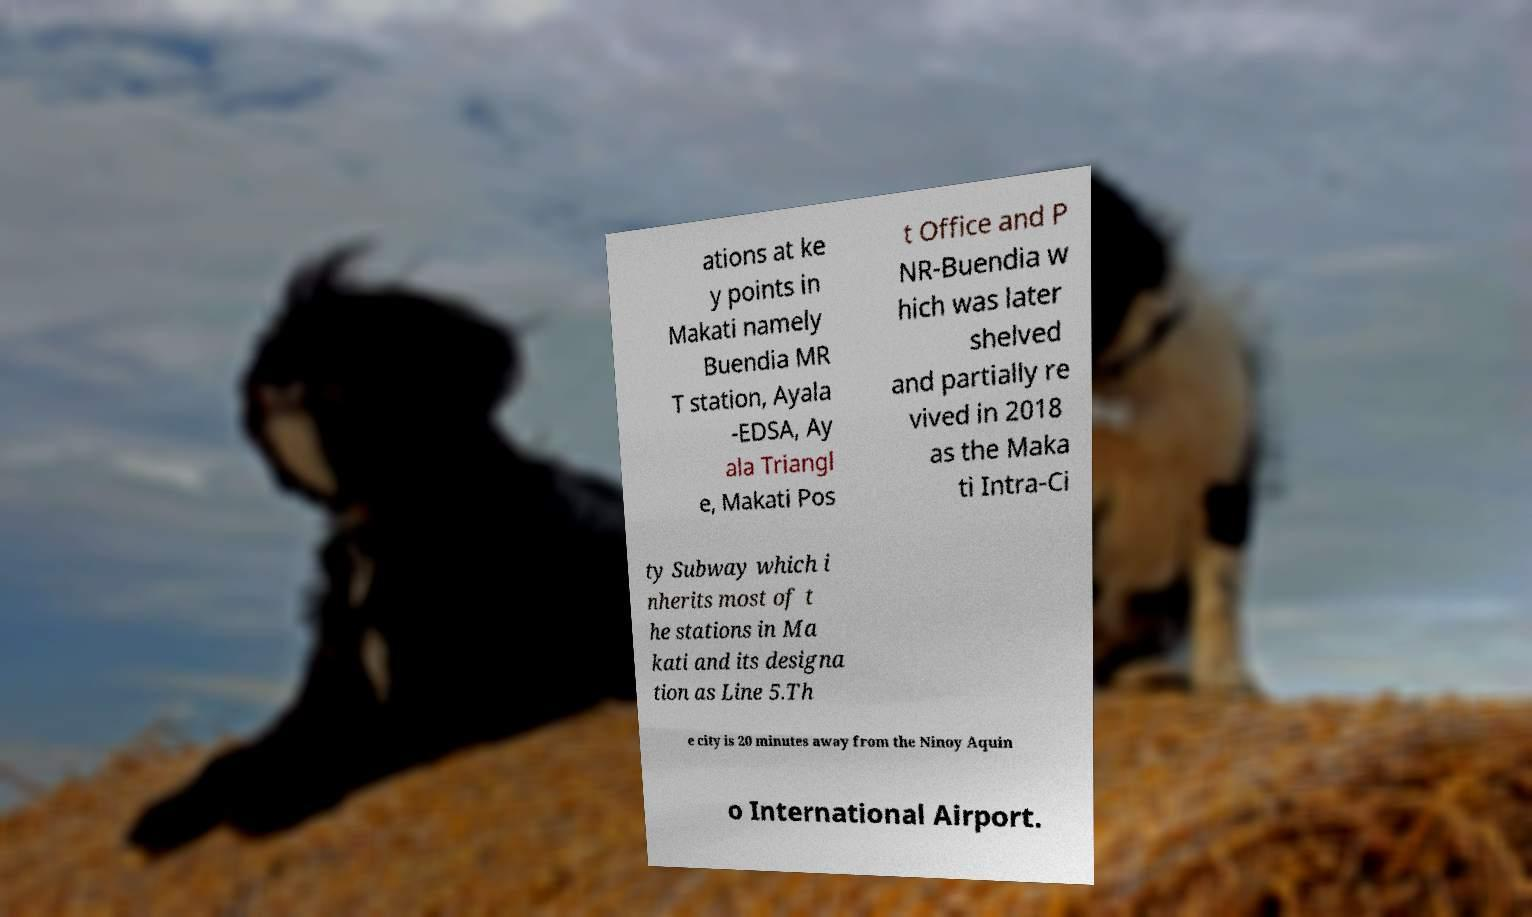Can you read and provide the text displayed in the image?This photo seems to have some interesting text. Can you extract and type it out for me? ations at ke y points in Makati namely Buendia MR T station, Ayala -EDSA, Ay ala Triangl e, Makati Pos t Office and P NR-Buendia w hich was later shelved and partially re vived in 2018 as the Maka ti Intra-Ci ty Subway which i nherits most of t he stations in Ma kati and its designa tion as Line 5.Th e city is 20 minutes away from the Ninoy Aquin o International Airport. 